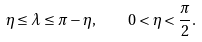<formula> <loc_0><loc_0><loc_500><loc_500>\eta \leq \lambda \leq \pi - \eta , \quad 0 < \eta < \frac { \pi } { 2 } .</formula> 